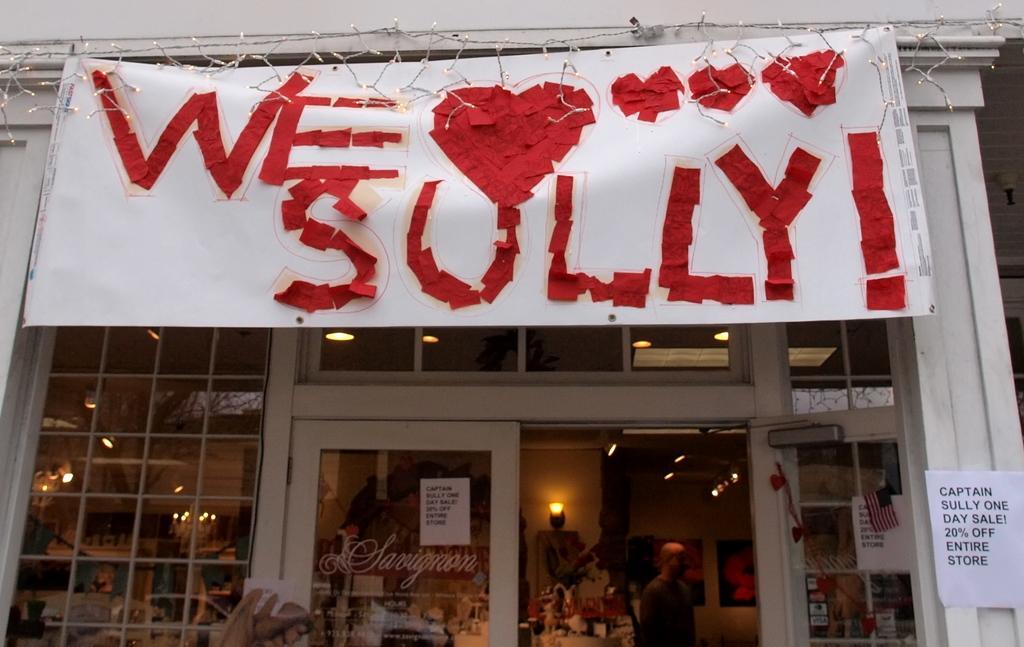Describe this image in one or two sentences. In this image in the center there is one building, and at the top there is one board. On the board there is text, and in the center there are some glass doors and in the building there are some persons and some objects and lights. On the right side and in the center there are some papers on the building, on the papers there is text and at the top there are some lights. 